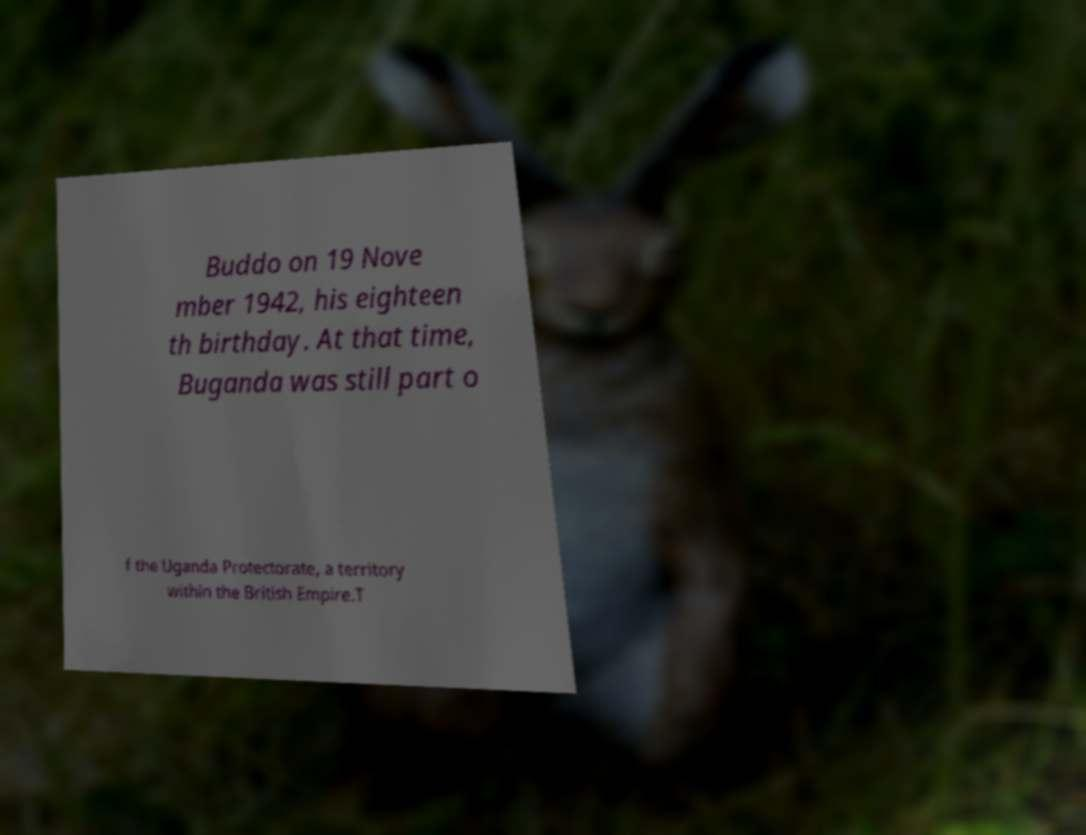Can you read and provide the text displayed in the image?This photo seems to have some interesting text. Can you extract and type it out for me? Buddo on 19 Nove mber 1942, his eighteen th birthday. At that time, Buganda was still part o f the Uganda Protectorate, a territory within the British Empire.T 